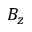Convert formula to latex. <formula><loc_0><loc_0><loc_500><loc_500>B _ { z }</formula> 